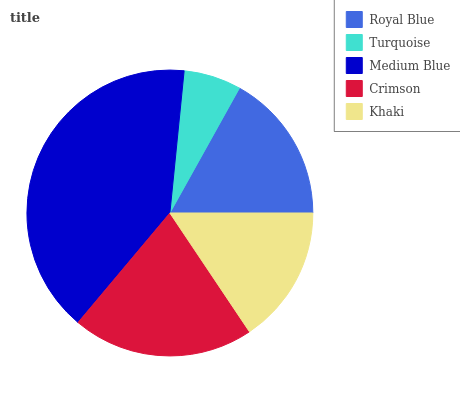Is Turquoise the minimum?
Answer yes or no. Yes. Is Medium Blue the maximum?
Answer yes or no. Yes. Is Medium Blue the minimum?
Answer yes or no. No. Is Turquoise the maximum?
Answer yes or no. No. Is Medium Blue greater than Turquoise?
Answer yes or no. Yes. Is Turquoise less than Medium Blue?
Answer yes or no. Yes. Is Turquoise greater than Medium Blue?
Answer yes or no. No. Is Medium Blue less than Turquoise?
Answer yes or no. No. Is Royal Blue the high median?
Answer yes or no. Yes. Is Royal Blue the low median?
Answer yes or no. Yes. Is Medium Blue the high median?
Answer yes or no. No. Is Turquoise the low median?
Answer yes or no. No. 